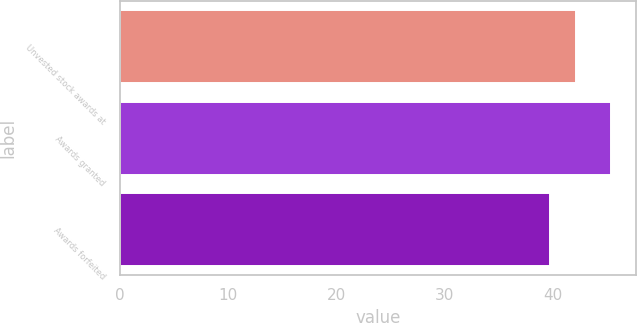Convert chart to OTSL. <chart><loc_0><loc_0><loc_500><loc_500><bar_chart><fcel>Unvested stock awards at<fcel>Awards granted<fcel>Awards forfeited<nl><fcel>42.11<fcel>45.41<fcel>39.75<nl></chart> 